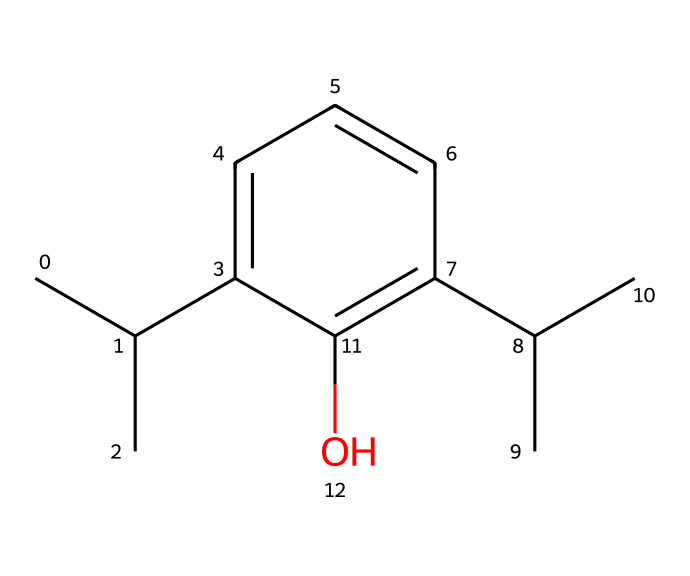What is the molecular formula of propofol? By analyzing the SMILES representation, we can count the individual atoms: there are 12 carbon atoms, 18 hydrogen atoms, and 1 oxygen atom. Combining these gives us the molecular formula C12H18O.
Answer: C12H18O How many rings are present in the structure of propofol? Looking at the SMILES representation, there are no ring structures indicated; therefore, the count of rings is zero.
Answer: 0 What functional group is present in the propofol structure? The presence of the -OH group (indicated by "O" in the SMILES) shows that propofol contains a hydroxyl functional group.
Answer: hydroxyl Which atoms in propofol contribute to its lipophilic character? The long carbon chain (C(C)C) and the aromatic ring (c1cccc(C(C)C)) enhance lipophilicity due to their non-polar characteristics.
Answer: carbon How does the arrangement of atoms in propofol affect its anesthetic properties? The branched aliphatic chains combined with the aromatic ring create a balance of lipophilicity and hydrophilicity, allowing for rapid redistribution in the nervous system, which is key for its anesthetic properties.
Answer: balance of lipophilicity and hydrophilicity What is the total number of hydrogen bonds that can be formed by propofol? The hydroxyl group (–OH) can form one hydrogen bond, while the structure allows for further interactions due to the presence of additional hydrogen atoms attached to carbon, but primarily the relevant hydrogen bond contributor is the hydroxyl group.
Answer: 1 Which part of propofol’s structure is primarily responsible for its rapid onset of action? The branched aliphatic portions, as they allow the compound to easily cross lipid membranes, leading to a rapid onset of action in the central nervous system.
Answer: branched aliphatic portions 